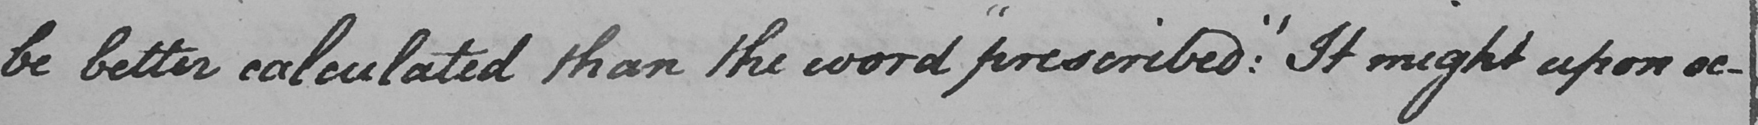What text is written in this handwritten line? be better calculated than the word  " prescribed :  "  It might upon oc- 